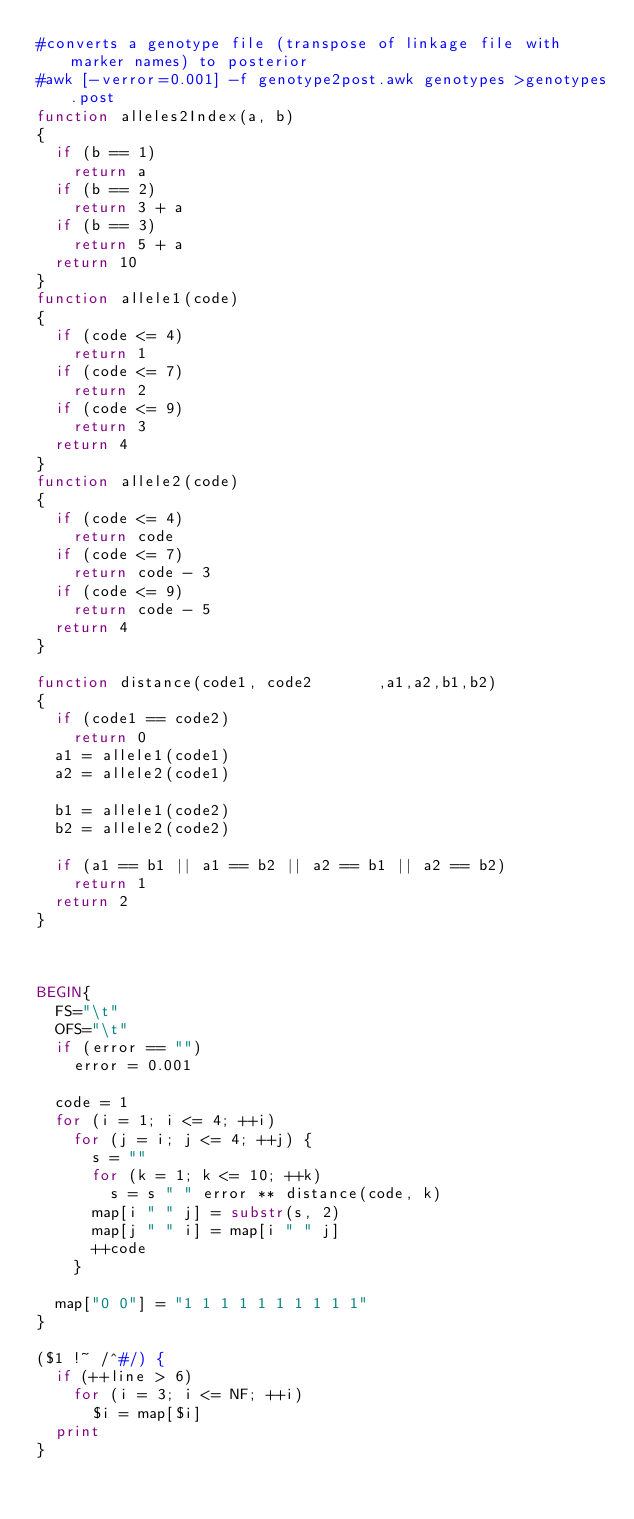<code> <loc_0><loc_0><loc_500><loc_500><_Awk_>#converts a genotype file (transpose of linkage file with marker names) to posterior
#awk [-verror=0.001] -f genotype2post.awk genotypes >genotypes.post
function alleles2Index(a, b)
{
	if (b == 1)
		return a
	if (b == 2)
		return 3 + a
	if (b == 3)
		return 5 + a
	return 10
}
function allele1(code)
{
	if (code <= 4)
		return 1
	if (code <= 7)
		return 2
	if (code <= 9)
		return 3
	return 4
}
function allele2(code)
{
	if (code <= 4)
		return code
	if (code <= 7)
		return code - 3
	if (code <= 9)
		return code - 5
	return 4
}

function distance(code1, code2       ,a1,a2,b1,b2)
{
	if (code1 == code2)
		return 0
	a1 = allele1(code1)
	a2 = allele2(code1)

	b1 = allele1(code2)
	b2 = allele2(code2)

	if (a1 == b1 || a1 == b2 || a2 == b1 || a2 == b2)
		return 1
	return 2
}



BEGIN{
	FS="\t"
	OFS="\t"
	if (error == "")
		error = 0.001

	code = 1
	for (i = 1; i <= 4; ++i)
		for (j = i; j <= 4; ++j) {
			s = ""
			for (k = 1; k <= 10; ++k)
				s = s " " error ** distance(code, k)
			map[i " " j] = substr(s, 2)
			map[j " " i] = map[i " " j]
			++code
		}

	map["0 0"] = "1 1 1 1 1 1 1 1 1 1"
}

($1 !~ /^#/) {
	if (++line > 6)
		for (i = 3; i <= NF; ++i)
			$i = map[$i]
	print
} 


</code> 